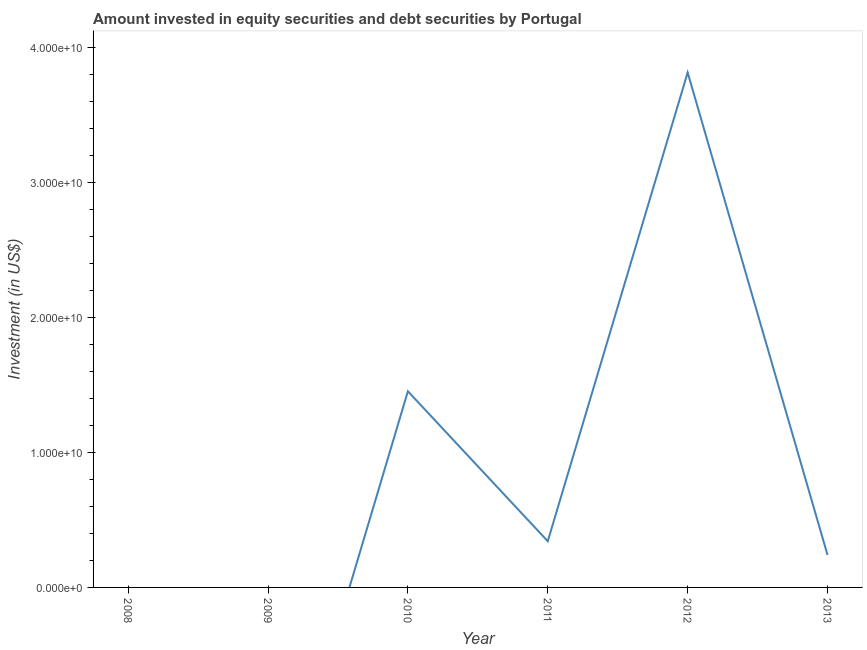What is the portfolio investment in 2013?
Make the answer very short. 2.40e+09. Across all years, what is the maximum portfolio investment?
Your answer should be very brief. 3.81e+1. In which year was the portfolio investment maximum?
Keep it short and to the point. 2012. What is the sum of the portfolio investment?
Offer a terse response. 5.85e+1. What is the difference between the portfolio investment in 2010 and 2012?
Offer a terse response. -2.36e+1. What is the average portfolio investment per year?
Offer a terse response. 9.75e+09. What is the median portfolio investment?
Offer a terse response. 2.91e+09. What is the ratio of the portfolio investment in 2012 to that in 2013?
Your answer should be very brief. 15.87. Is the portfolio investment in 2010 less than that in 2012?
Offer a terse response. Yes. What is the difference between the highest and the second highest portfolio investment?
Provide a succinct answer. 2.36e+1. Is the sum of the portfolio investment in 2010 and 2011 greater than the maximum portfolio investment across all years?
Offer a terse response. No. What is the difference between the highest and the lowest portfolio investment?
Offer a very short reply. 3.81e+1. In how many years, is the portfolio investment greater than the average portfolio investment taken over all years?
Keep it short and to the point. 2. How many lines are there?
Offer a terse response. 1. How many years are there in the graph?
Ensure brevity in your answer.  6. Does the graph contain any zero values?
Make the answer very short. Yes. Does the graph contain grids?
Ensure brevity in your answer.  No. What is the title of the graph?
Your answer should be very brief. Amount invested in equity securities and debt securities by Portugal. What is the label or title of the Y-axis?
Keep it short and to the point. Investment (in US$). What is the Investment (in US$) in 2008?
Your response must be concise. 0. What is the Investment (in US$) in 2009?
Give a very brief answer. 0. What is the Investment (in US$) in 2010?
Provide a short and direct response. 1.45e+1. What is the Investment (in US$) of 2011?
Ensure brevity in your answer.  3.42e+09. What is the Investment (in US$) of 2012?
Make the answer very short. 3.81e+1. What is the Investment (in US$) in 2013?
Offer a terse response. 2.40e+09. What is the difference between the Investment (in US$) in 2010 and 2011?
Ensure brevity in your answer.  1.11e+1. What is the difference between the Investment (in US$) in 2010 and 2012?
Offer a very short reply. -2.36e+1. What is the difference between the Investment (in US$) in 2010 and 2013?
Give a very brief answer. 1.21e+1. What is the difference between the Investment (in US$) in 2011 and 2012?
Keep it short and to the point. -3.47e+1. What is the difference between the Investment (in US$) in 2011 and 2013?
Provide a succinct answer. 1.02e+09. What is the difference between the Investment (in US$) in 2012 and 2013?
Keep it short and to the point. 3.57e+1. What is the ratio of the Investment (in US$) in 2010 to that in 2011?
Give a very brief answer. 4.25. What is the ratio of the Investment (in US$) in 2010 to that in 2012?
Keep it short and to the point. 0.38. What is the ratio of the Investment (in US$) in 2010 to that in 2013?
Your answer should be compact. 6.05. What is the ratio of the Investment (in US$) in 2011 to that in 2012?
Provide a short and direct response. 0.09. What is the ratio of the Investment (in US$) in 2011 to that in 2013?
Offer a very short reply. 1.42. What is the ratio of the Investment (in US$) in 2012 to that in 2013?
Give a very brief answer. 15.87. 